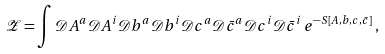Convert formula to latex. <formula><loc_0><loc_0><loc_500><loc_500>\mathcal { Z } = \int \mathcal { D } A ^ { a } \mathcal { D } A ^ { i } \mathcal { D } b ^ { a } \mathcal { D } b ^ { i } \mathcal { D } c ^ { a } \mathcal { D } \bar { c } ^ { a } \mathcal { D } c ^ { i } \mathcal { D } \bar { c } ^ { i } \, e ^ { - S [ A , b , c , \bar { c } ] } \, ,</formula> 